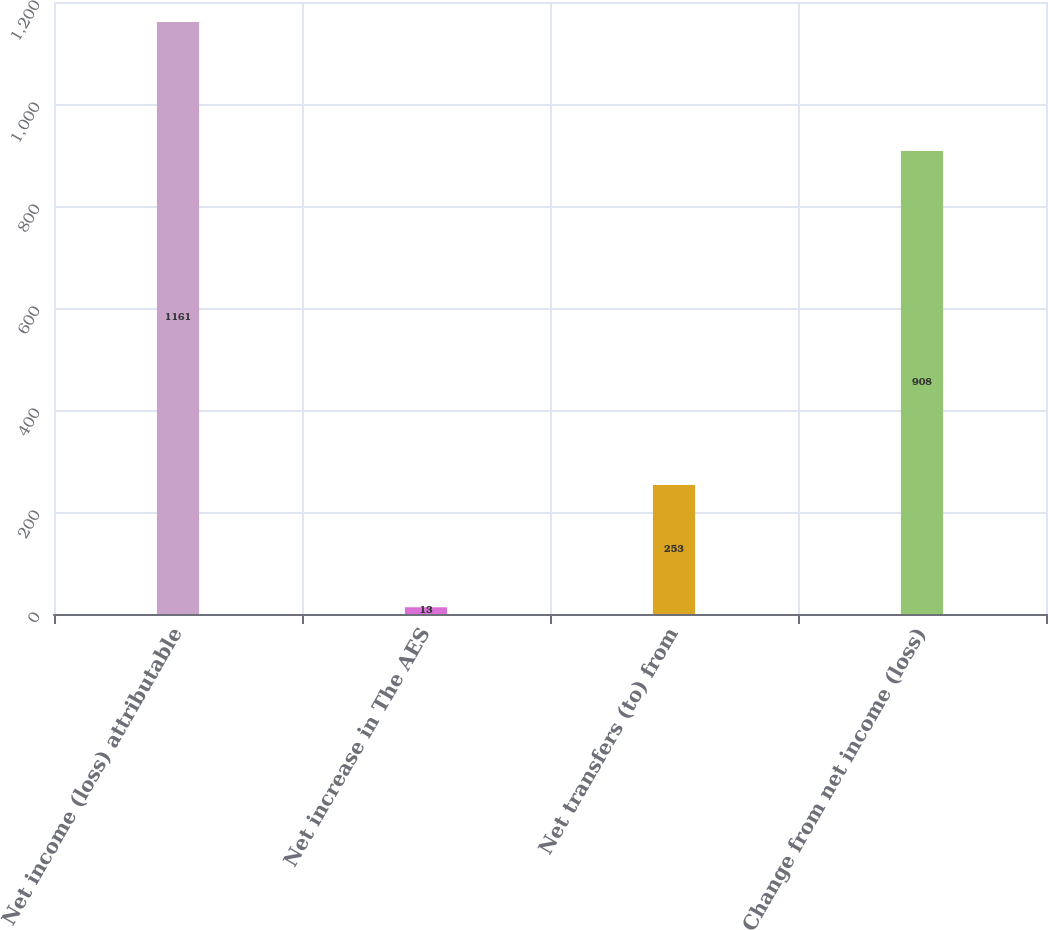<chart> <loc_0><loc_0><loc_500><loc_500><bar_chart><fcel>Net income (loss) attributable<fcel>Net increase in The AES<fcel>Net transfers (to) from<fcel>Change from net income (loss)<nl><fcel>1161<fcel>13<fcel>253<fcel>908<nl></chart> 